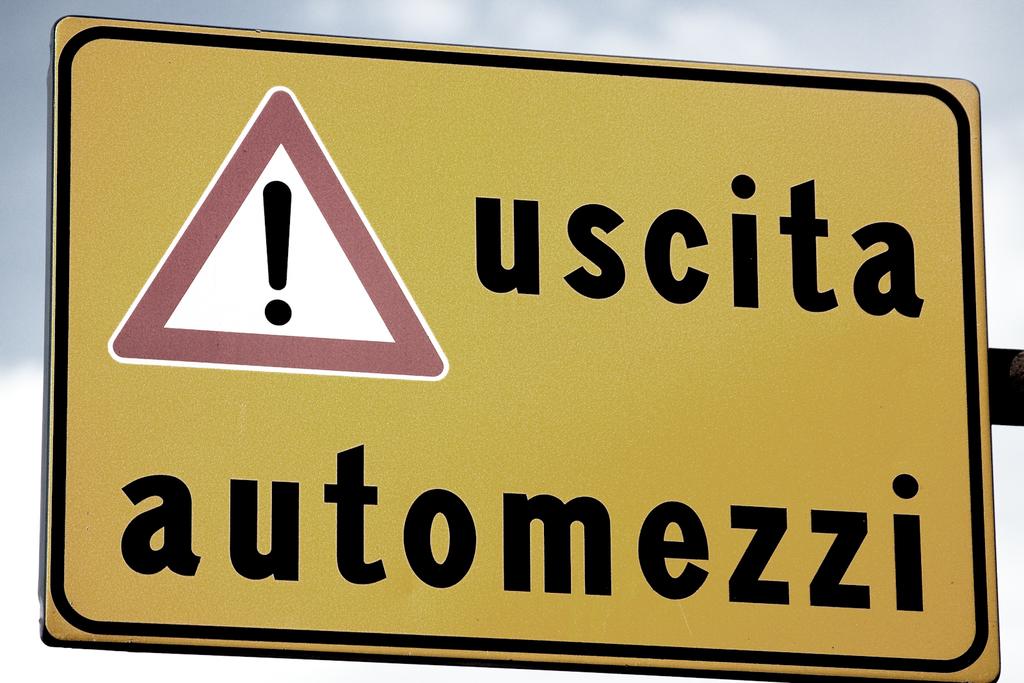Is "uscita automezzi" italian?
Make the answer very short. Unanswerable. 